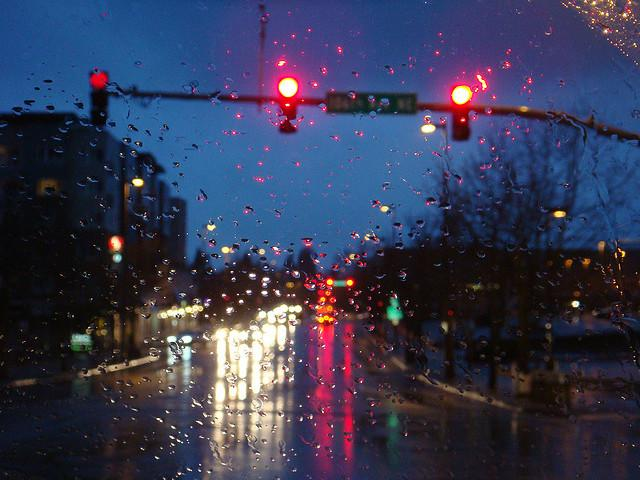What's seen on the window? Please explain your reasoning. raindrops. It is raining and you can see the glare on the road. 